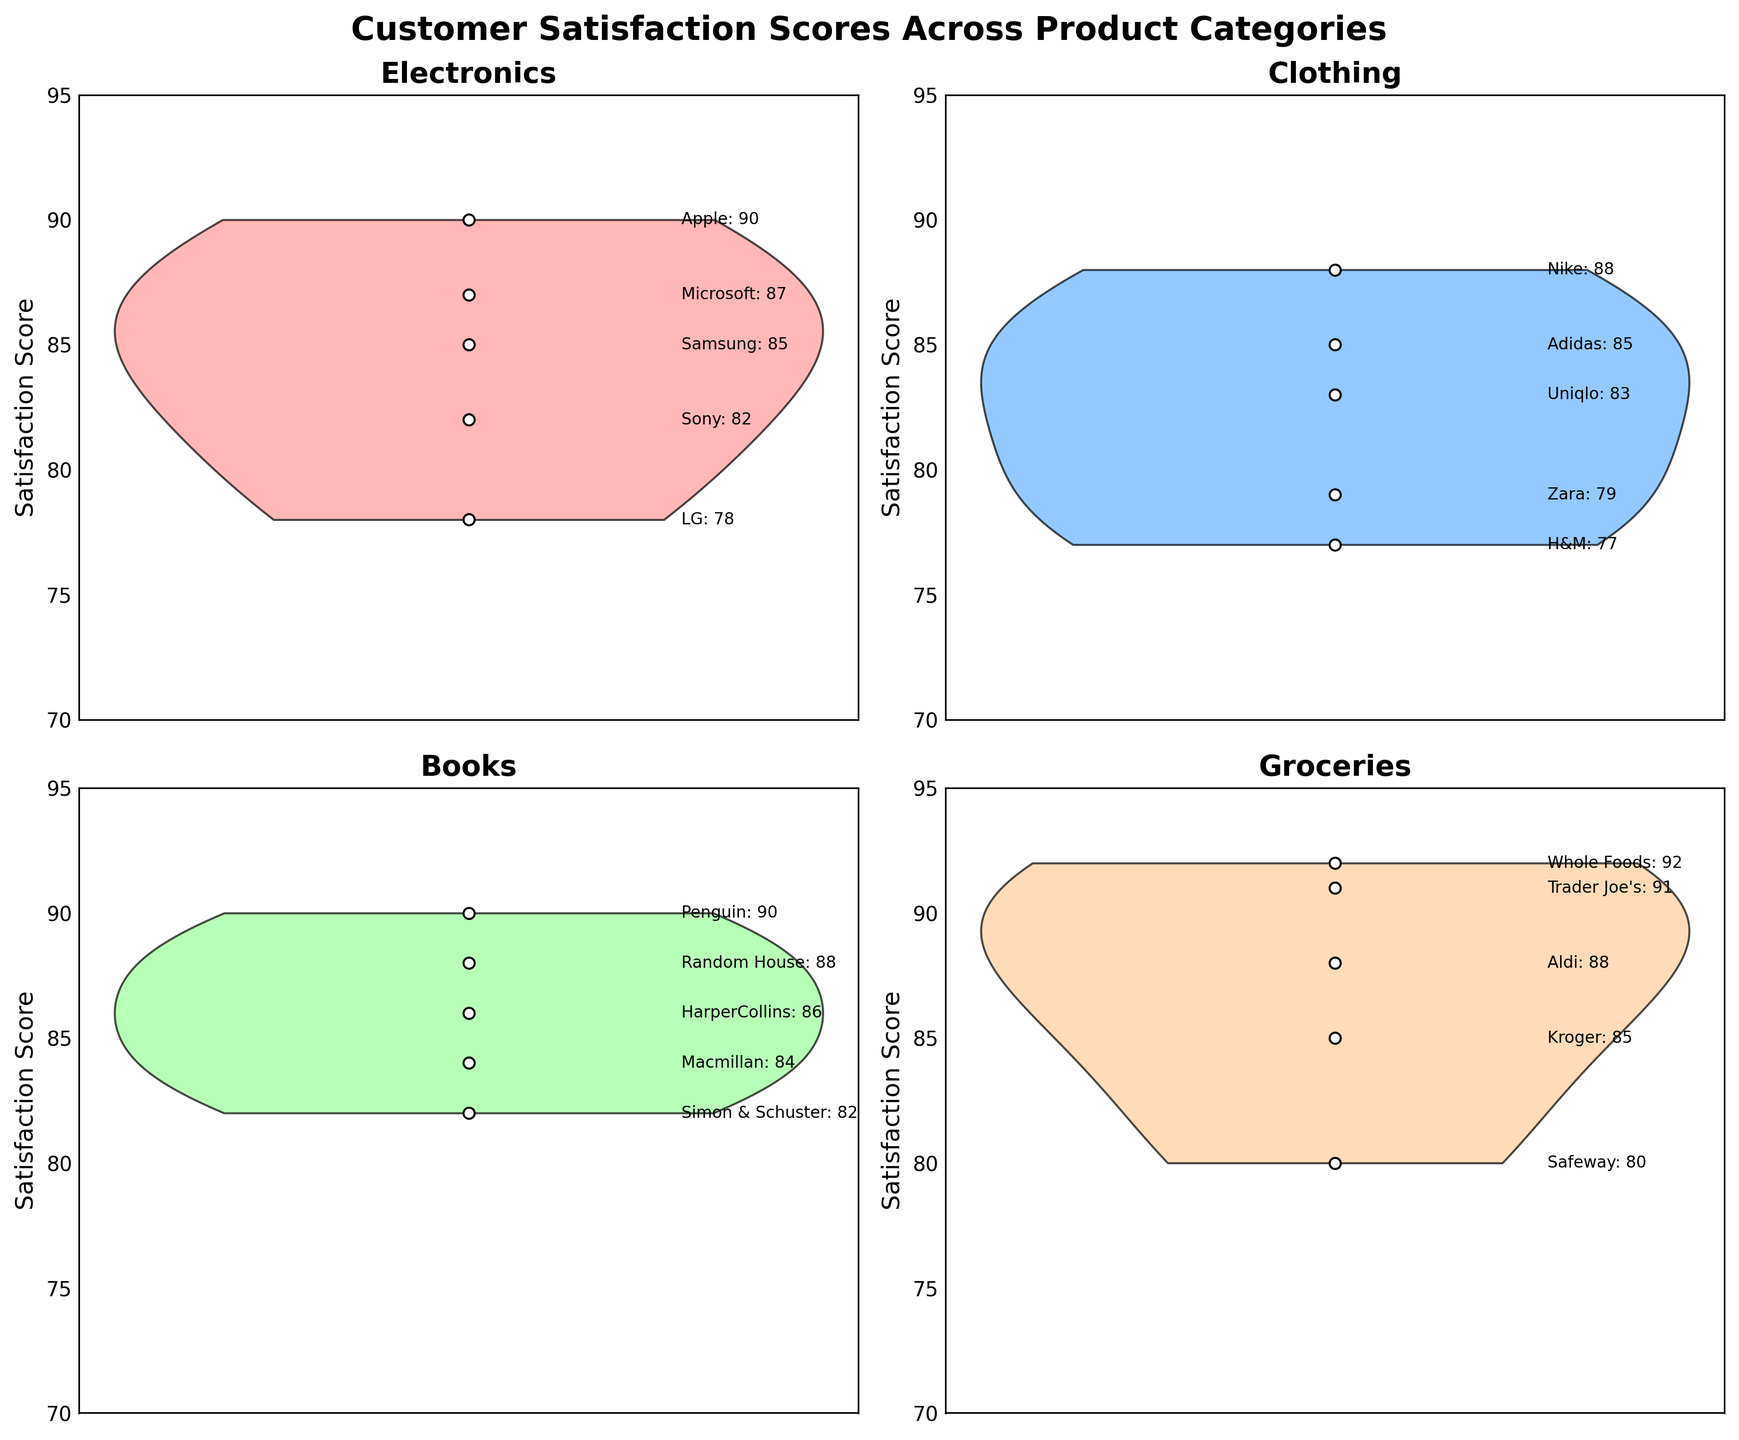What's the title of the figure? Look at the top of the figure where the title is usually located. The title should summarize the content of the figure.
Answer: Customer Satisfaction Scores Across Product Categories How many product categories are displayed in the figure? Count the number of unique categories shown by the separate subplots. Each subplot represents a different product category.
Answer: 4 Which product category has the highest individual satisfaction score, and what is that score? Look at each subplot and identify the highest satisfaction score in each. The highest score overall will be the highest among these values.
Answer: Groceries, 92 Compare the median satisfaction scores of the 'Electronics' and 'Books' categories. Which one is higher? Estimate the median by visually inspecting the middle value range of the violin plots. Compare the medians of the two categories.
Answer: Books What is the range of satisfaction scores for the 'Clothing' category? Identify the lowest and highest points on the violin plot for the 'Clothing' category and calculate the difference.
Answer: 77-88 Which product category shows the most spread in satisfaction scores? Observe which violin plot is the widest (longest) vertically. This indicates the most variation in satisfaction scores.
Answer: Clothing How many brands are there in the 'Groceries' category? Count the number of individual data points (scatter points) or text labels beside each point in the 'Groceries' subplot.
Answer: 5 Compare the satisfaction scores of 'Nike' and 'Adidas' in the 'Clothing' category. Which one is higher? Locate both 'Nike' and 'Adidas' satisfaction scores in the 'Clothing' subplot and compare them directly.
Answer: Nike For which category do all brands have satisfaction scores higher than 80? Check each subplot to see which one only contains satisfaction scores above 80.
Answer: Groceries 